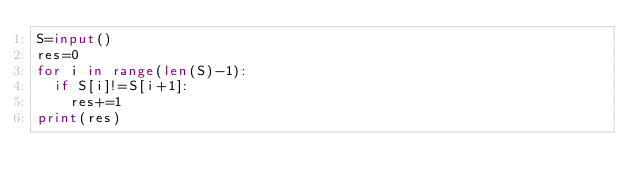<code> <loc_0><loc_0><loc_500><loc_500><_Python_>S=input()
res=0
for i in range(len(S)-1):
  if S[i]!=S[i+1]:
    res+=1
print(res)</code> 